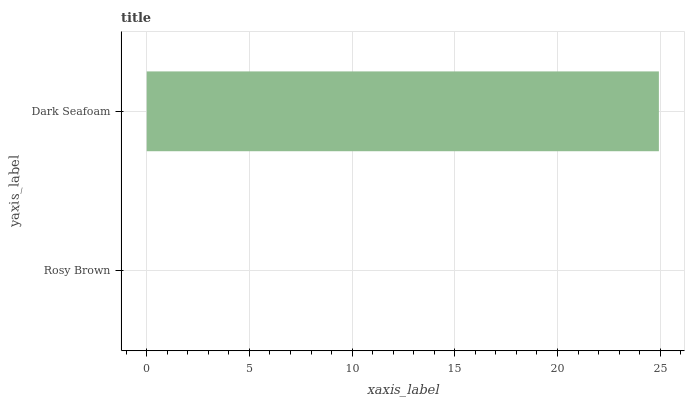Is Rosy Brown the minimum?
Answer yes or no. Yes. Is Dark Seafoam the maximum?
Answer yes or no. Yes. Is Dark Seafoam the minimum?
Answer yes or no. No. Is Dark Seafoam greater than Rosy Brown?
Answer yes or no. Yes. Is Rosy Brown less than Dark Seafoam?
Answer yes or no. Yes. Is Rosy Brown greater than Dark Seafoam?
Answer yes or no. No. Is Dark Seafoam less than Rosy Brown?
Answer yes or no. No. Is Dark Seafoam the high median?
Answer yes or no. Yes. Is Rosy Brown the low median?
Answer yes or no. Yes. Is Rosy Brown the high median?
Answer yes or no. No. Is Dark Seafoam the low median?
Answer yes or no. No. 